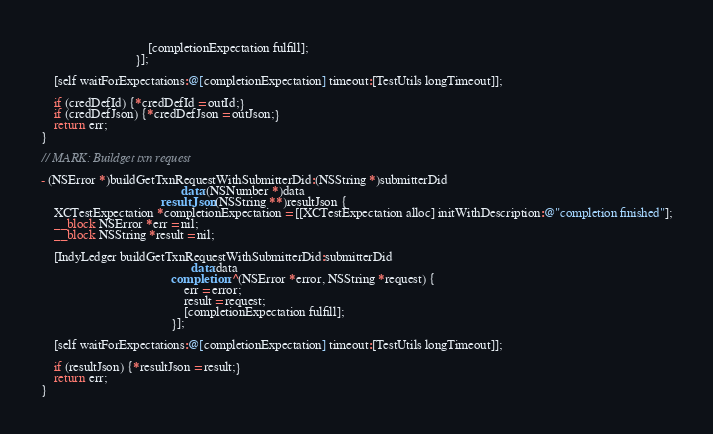Convert code to text. <code><loc_0><loc_0><loc_500><loc_500><_ObjectiveC_>                                 [completionExpectation fulfill];
                             }];

    [self waitForExpectations:@[completionExpectation] timeout:[TestUtils longTimeout]];

    if (credDefId) {*credDefId = outId;}
    if (credDefJson) {*credDefJson = outJson;}
    return err;
}

// MARK: Buildget txn request

- (NSError *)buildGetTxnRequestWithSubmitterDid:(NSString *)submitterDid
                                           data:(NSNumber *)data
                                     resultJson:(NSString **)resultJson {
    XCTestExpectation *completionExpectation = [[XCTestExpectation alloc] initWithDescription:@"completion finished"];
    __block NSError *err = nil;
    __block NSString *result = nil;

    [IndyLedger buildGetTxnRequestWithSubmitterDid:submitterDid
                                              data:data
                                        completion:^(NSError *error, NSString *request) {
                                            err = error;
                                            result = request;
                                            [completionExpectation fulfill];
                                        }];

    [self waitForExpectations:@[completionExpectation] timeout:[TestUtils longTimeout]];

    if (resultJson) {*resultJson = result;}
    return err;
}
</code> 